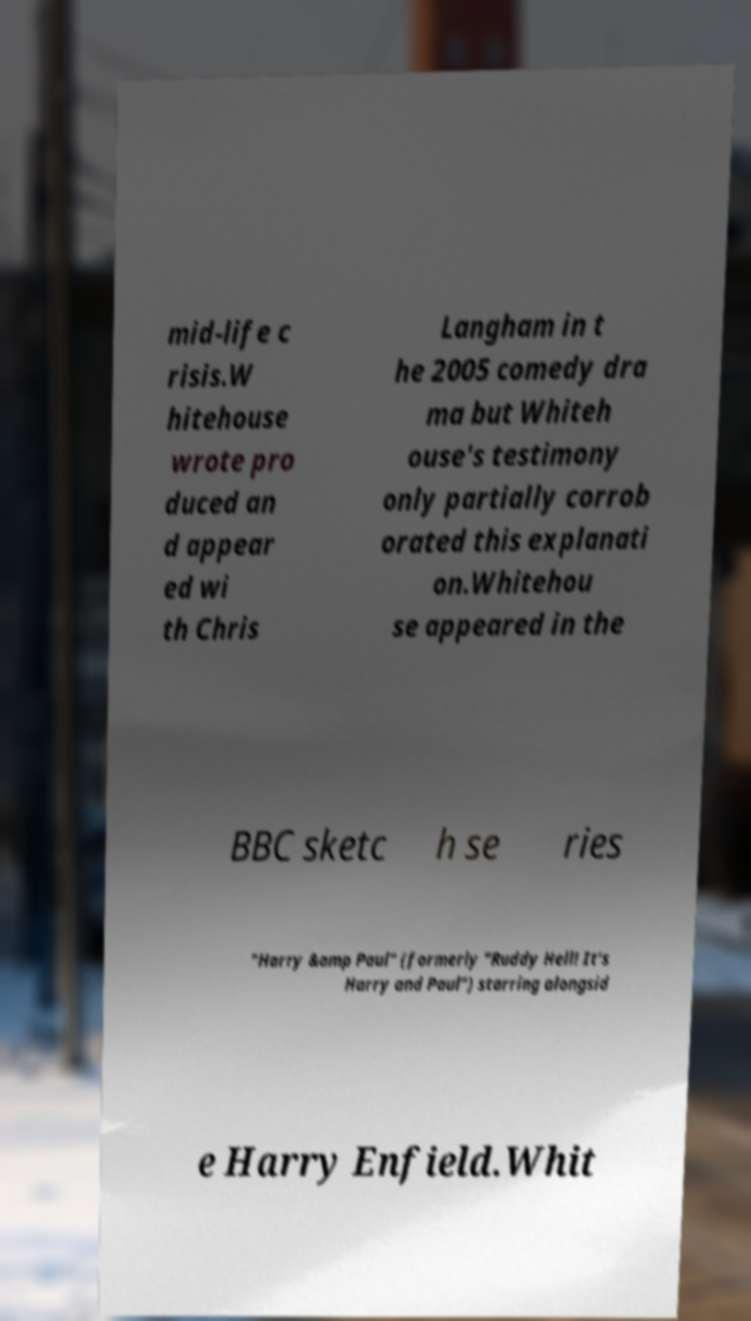There's text embedded in this image that I need extracted. Can you transcribe it verbatim? mid-life c risis.W hitehouse wrote pro duced an d appear ed wi th Chris Langham in t he 2005 comedy dra ma but Whiteh ouse's testimony only partially corrob orated this explanati on.Whitehou se appeared in the BBC sketc h se ries "Harry &amp Paul" (formerly "Ruddy Hell! It's Harry and Paul") starring alongsid e Harry Enfield.Whit 